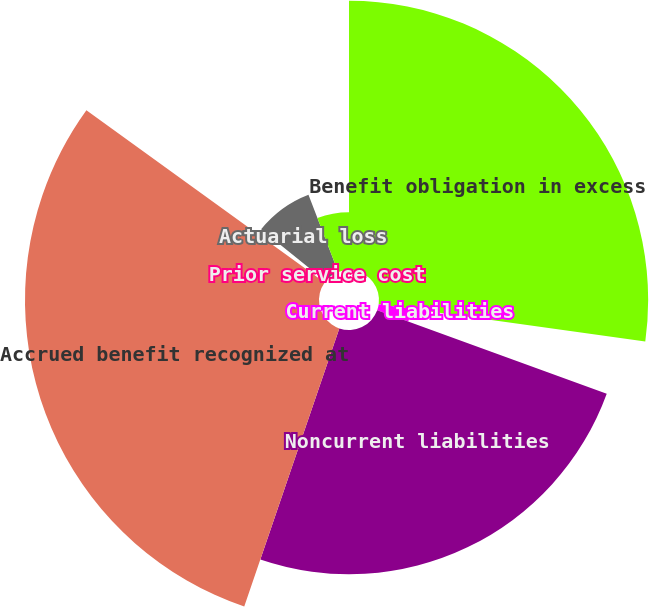Convert chart. <chart><loc_0><loc_0><loc_500><loc_500><pie_chart><fcel>Benefit obligation in excess<fcel>Current liabilities<fcel>Noncurrent liabilities<fcel>Accrued benefit recognized at<fcel>Prior service cost<fcel>Actuarial loss<fcel>Total<nl><fcel>27.21%<fcel>3.34%<fcel>24.69%<fcel>29.72%<fcel>0.82%<fcel>8.37%<fcel>5.85%<nl></chart> 